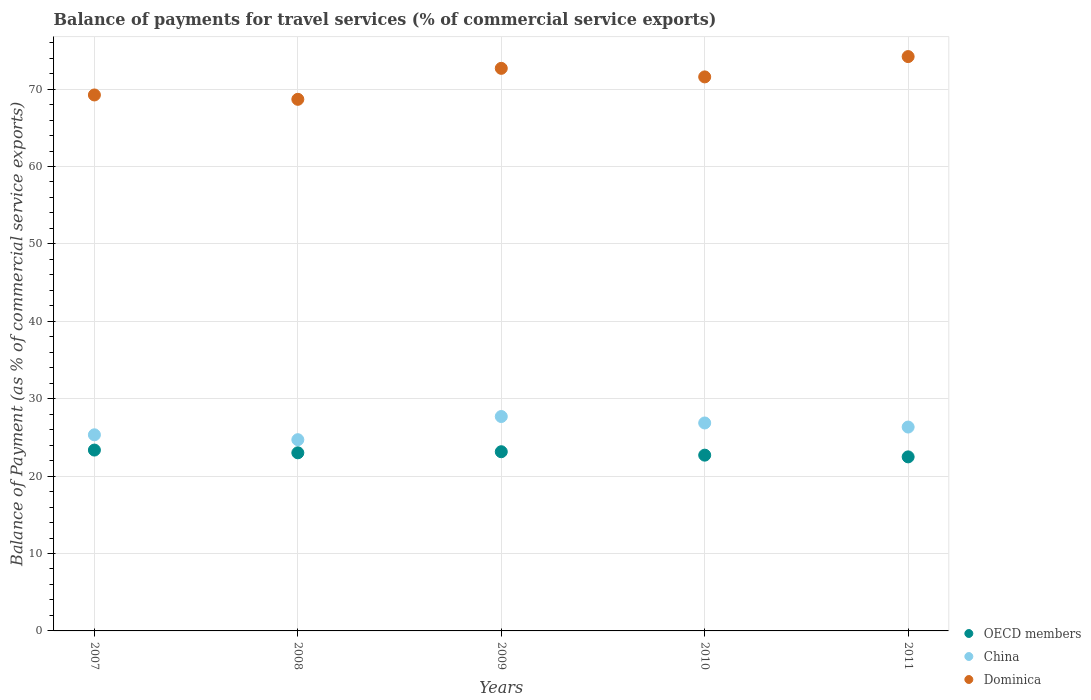Is the number of dotlines equal to the number of legend labels?
Give a very brief answer. Yes. What is the balance of payments for travel services in Dominica in 2010?
Keep it short and to the point. 71.57. Across all years, what is the maximum balance of payments for travel services in OECD members?
Your response must be concise. 23.36. Across all years, what is the minimum balance of payments for travel services in China?
Your answer should be compact. 24.7. In which year was the balance of payments for travel services in Dominica maximum?
Your answer should be compact. 2011. In which year was the balance of payments for travel services in OECD members minimum?
Your answer should be very brief. 2011. What is the total balance of payments for travel services in OECD members in the graph?
Offer a very short reply. 114.72. What is the difference between the balance of payments for travel services in Dominica in 2007 and that in 2011?
Make the answer very short. -4.96. What is the difference between the balance of payments for travel services in Dominica in 2011 and the balance of payments for travel services in China in 2008?
Give a very brief answer. 49.49. What is the average balance of payments for travel services in Dominica per year?
Offer a very short reply. 71.27. In the year 2011, what is the difference between the balance of payments for travel services in OECD members and balance of payments for travel services in Dominica?
Provide a short and direct response. -51.71. In how many years, is the balance of payments for travel services in Dominica greater than 66 %?
Give a very brief answer. 5. What is the ratio of the balance of payments for travel services in Dominica in 2007 to that in 2010?
Your answer should be compact. 0.97. Is the difference between the balance of payments for travel services in OECD members in 2008 and 2010 greater than the difference between the balance of payments for travel services in Dominica in 2008 and 2010?
Provide a succinct answer. Yes. What is the difference between the highest and the second highest balance of payments for travel services in China?
Provide a short and direct response. 0.83. What is the difference between the highest and the lowest balance of payments for travel services in OECD members?
Give a very brief answer. 0.88. In how many years, is the balance of payments for travel services in OECD members greater than the average balance of payments for travel services in OECD members taken over all years?
Offer a very short reply. 3. Is the sum of the balance of payments for travel services in OECD members in 2009 and 2011 greater than the maximum balance of payments for travel services in China across all years?
Keep it short and to the point. Yes. Is it the case that in every year, the sum of the balance of payments for travel services in OECD members and balance of payments for travel services in Dominica  is greater than the balance of payments for travel services in China?
Your answer should be compact. Yes. Is the balance of payments for travel services in China strictly greater than the balance of payments for travel services in OECD members over the years?
Ensure brevity in your answer.  Yes. Is the balance of payments for travel services in Dominica strictly less than the balance of payments for travel services in China over the years?
Your answer should be very brief. No. Are the values on the major ticks of Y-axis written in scientific E-notation?
Offer a very short reply. No. How are the legend labels stacked?
Your answer should be very brief. Vertical. What is the title of the graph?
Give a very brief answer. Balance of payments for travel services (% of commercial service exports). Does "St. Martin (French part)" appear as one of the legend labels in the graph?
Offer a terse response. No. What is the label or title of the X-axis?
Give a very brief answer. Years. What is the label or title of the Y-axis?
Provide a short and direct response. Balance of Payment (as % of commercial service exports). What is the Balance of Payment (as % of commercial service exports) of OECD members in 2007?
Offer a terse response. 23.36. What is the Balance of Payment (as % of commercial service exports) in China in 2007?
Provide a short and direct response. 25.34. What is the Balance of Payment (as % of commercial service exports) in Dominica in 2007?
Give a very brief answer. 69.24. What is the Balance of Payment (as % of commercial service exports) in OECD members in 2008?
Provide a succinct answer. 23.01. What is the Balance of Payment (as % of commercial service exports) of China in 2008?
Offer a very short reply. 24.7. What is the Balance of Payment (as % of commercial service exports) in Dominica in 2008?
Offer a very short reply. 68.68. What is the Balance of Payment (as % of commercial service exports) in OECD members in 2009?
Give a very brief answer. 23.15. What is the Balance of Payment (as % of commercial service exports) in China in 2009?
Ensure brevity in your answer.  27.7. What is the Balance of Payment (as % of commercial service exports) in Dominica in 2009?
Your response must be concise. 72.68. What is the Balance of Payment (as % of commercial service exports) in OECD members in 2010?
Your response must be concise. 22.71. What is the Balance of Payment (as % of commercial service exports) of China in 2010?
Offer a terse response. 26.86. What is the Balance of Payment (as % of commercial service exports) of Dominica in 2010?
Provide a succinct answer. 71.57. What is the Balance of Payment (as % of commercial service exports) in OECD members in 2011?
Offer a very short reply. 22.48. What is the Balance of Payment (as % of commercial service exports) in China in 2011?
Offer a very short reply. 26.34. What is the Balance of Payment (as % of commercial service exports) in Dominica in 2011?
Ensure brevity in your answer.  74.2. Across all years, what is the maximum Balance of Payment (as % of commercial service exports) of OECD members?
Your answer should be very brief. 23.36. Across all years, what is the maximum Balance of Payment (as % of commercial service exports) of China?
Provide a succinct answer. 27.7. Across all years, what is the maximum Balance of Payment (as % of commercial service exports) of Dominica?
Provide a succinct answer. 74.2. Across all years, what is the minimum Balance of Payment (as % of commercial service exports) of OECD members?
Give a very brief answer. 22.48. Across all years, what is the minimum Balance of Payment (as % of commercial service exports) of China?
Provide a short and direct response. 24.7. Across all years, what is the minimum Balance of Payment (as % of commercial service exports) in Dominica?
Provide a short and direct response. 68.68. What is the total Balance of Payment (as % of commercial service exports) of OECD members in the graph?
Make the answer very short. 114.72. What is the total Balance of Payment (as % of commercial service exports) in China in the graph?
Ensure brevity in your answer.  130.94. What is the total Balance of Payment (as % of commercial service exports) of Dominica in the graph?
Provide a short and direct response. 356.37. What is the difference between the Balance of Payment (as % of commercial service exports) of OECD members in 2007 and that in 2008?
Ensure brevity in your answer.  0.35. What is the difference between the Balance of Payment (as % of commercial service exports) of China in 2007 and that in 2008?
Your answer should be very brief. 0.63. What is the difference between the Balance of Payment (as % of commercial service exports) of Dominica in 2007 and that in 2008?
Provide a succinct answer. 0.56. What is the difference between the Balance of Payment (as % of commercial service exports) in OECD members in 2007 and that in 2009?
Provide a succinct answer. 0.21. What is the difference between the Balance of Payment (as % of commercial service exports) in China in 2007 and that in 2009?
Offer a very short reply. -2.36. What is the difference between the Balance of Payment (as % of commercial service exports) of Dominica in 2007 and that in 2009?
Your answer should be very brief. -3.44. What is the difference between the Balance of Payment (as % of commercial service exports) in OECD members in 2007 and that in 2010?
Provide a short and direct response. 0.66. What is the difference between the Balance of Payment (as % of commercial service exports) of China in 2007 and that in 2010?
Ensure brevity in your answer.  -1.53. What is the difference between the Balance of Payment (as % of commercial service exports) in Dominica in 2007 and that in 2010?
Offer a very short reply. -2.33. What is the difference between the Balance of Payment (as % of commercial service exports) in OECD members in 2007 and that in 2011?
Provide a succinct answer. 0.88. What is the difference between the Balance of Payment (as % of commercial service exports) of China in 2007 and that in 2011?
Your answer should be very brief. -1. What is the difference between the Balance of Payment (as % of commercial service exports) in Dominica in 2007 and that in 2011?
Your answer should be compact. -4.96. What is the difference between the Balance of Payment (as % of commercial service exports) of OECD members in 2008 and that in 2009?
Give a very brief answer. -0.14. What is the difference between the Balance of Payment (as % of commercial service exports) in China in 2008 and that in 2009?
Your answer should be compact. -2.99. What is the difference between the Balance of Payment (as % of commercial service exports) in Dominica in 2008 and that in 2009?
Your answer should be compact. -4. What is the difference between the Balance of Payment (as % of commercial service exports) of OECD members in 2008 and that in 2010?
Your answer should be compact. 0.3. What is the difference between the Balance of Payment (as % of commercial service exports) of China in 2008 and that in 2010?
Provide a succinct answer. -2.16. What is the difference between the Balance of Payment (as % of commercial service exports) of Dominica in 2008 and that in 2010?
Offer a very short reply. -2.9. What is the difference between the Balance of Payment (as % of commercial service exports) of OECD members in 2008 and that in 2011?
Make the answer very short. 0.53. What is the difference between the Balance of Payment (as % of commercial service exports) in China in 2008 and that in 2011?
Your answer should be very brief. -1.63. What is the difference between the Balance of Payment (as % of commercial service exports) of Dominica in 2008 and that in 2011?
Offer a very short reply. -5.52. What is the difference between the Balance of Payment (as % of commercial service exports) in OECD members in 2009 and that in 2010?
Keep it short and to the point. 0.44. What is the difference between the Balance of Payment (as % of commercial service exports) in China in 2009 and that in 2010?
Your response must be concise. 0.83. What is the difference between the Balance of Payment (as % of commercial service exports) in Dominica in 2009 and that in 2010?
Offer a very short reply. 1.1. What is the difference between the Balance of Payment (as % of commercial service exports) in OECD members in 2009 and that in 2011?
Your answer should be compact. 0.67. What is the difference between the Balance of Payment (as % of commercial service exports) in China in 2009 and that in 2011?
Your response must be concise. 1.36. What is the difference between the Balance of Payment (as % of commercial service exports) in Dominica in 2009 and that in 2011?
Give a very brief answer. -1.52. What is the difference between the Balance of Payment (as % of commercial service exports) in OECD members in 2010 and that in 2011?
Make the answer very short. 0.22. What is the difference between the Balance of Payment (as % of commercial service exports) of China in 2010 and that in 2011?
Ensure brevity in your answer.  0.53. What is the difference between the Balance of Payment (as % of commercial service exports) in Dominica in 2010 and that in 2011?
Your answer should be very brief. -2.62. What is the difference between the Balance of Payment (as % of commercial service exports) in OECD members in 2007 and the Balance of Payment (as % of commercial service exports) in China in 2008?
Offer a terse response. -1.34. What is the difference between the Balance of Payment (as % of commercial service exports) of OECD members in 2007 and the Balance of Payment (as % of commercial service exports) of Dominica in 2008?
Ensure brevity in your answer.  -45.31. What is the difference between the Balance of Payment (as % of commercial service exports) of China in 2007 and the Balance of Payment (as % of commercial service exports) of Dominica in 2008?
Provide a short and direct response. -43.34. What is the difference between the Balance of Payment (as % of commercial service exports) of OECD members in 2007 and the Balance of Payment (as % of commercial service exports) of China in 2009?
Your answer should be very brief. -4.33. What is the difference between the Balance of Payment (as % of commercial service exports) of OECD members in 2007 and the Balance of Payment (as % of commercial service exports) of Dominica in 2009?
Make the answer very short. -49.31. What is the difference between the Balance of Payment (as % of commercial service exports) of China in 2007 and the Balance of Payment (as % of commercial service exports) of Dominica in 2009?
Offer a terse response. -47.34. What is the difference between the Balance of Payment (as % of commercial service exports) in OECD members in 2007 and the Balance of Payment (as % of commercial service exports) in China in 2010?
Your response must be concise. -3.5. What is the difference between the Balance of Payment (as % of commercial service exports) of OECD members in 2007 and the Balance of Payment (as % of commercial service exports) of Dominica in 2010?
Give a very brief answer. -48.21. What is the difference between the Balance of Payment (as % of commercial service exports) of China in 2007 and the Balance of Payment (as % of commercial service exports) of Dominica in 2010?
Keep it short and to the point. -46.24. What is the difference between the Balance of Payment (as % of commercial service exports) of OECD members in 2007 and the Balance of Payment (as % of commercial service exports) of China in 2011?
Your response must be concise. -2.97. What is the difference between the Balance of Payment (as % of commercial service exports) of OECD members in 2007 and the Balance of Payment (as % of commercial service exports) of Dominica in 2011?
Provide a succinct answer. -50.83. What is the difference between the Balance of Payment (as % of commercial service exports) of China in 2007 and the Balance of Payment (as % of commercial service exports) of Dominica in 2011?
Give a very brief answer. -48.86. What is the difference between the Balance of Payment (as % of commercial service exports) of OECD members in 2008 and the Balance of Payment (as % of commercial service exports) of China in 2009?
Offer a very short reply. -4.69. What is the difference between the Balance of Payment (as % of commercial service exports) in OECD members in 2008 and the Balance of Payment (as % of commercial service exports) in Dominica in 2009?
Your response must be concise. -49.67. What is the difference between the Balance of Payment (as % of commercial service exports) of China in 2008 and the Balance of Payment (as % of commercial service exports) of Dominica in 2009?
Offer a very short reply. -47.97. What is the difference between the Balance of Payment (as % of commercial service exports) of OECD members in 2008 and the Balance of Payment (as % of commercial service exports) of China in 2010?
Provide a succinct answer. -3.85. What is the difference between the Balance of Payment (as % of commercial service exports) of OECD members in 2008 and the Balance of Payment (as % of commercial service exports) of Dominica in 2010?
Provide a short and direct response. -48.56. What is the difference between the Balance of Payment (as % of commercial service exports) of China in 2008 and the Balance of Payment (as % of commercial service exports) of Dominica in 2010?
Your response must be concise. -46.87. What is the difference between the Balance of Payment (as % of commercial service exports) of OECD members in 2008 and the Balance of Payment (as % of commercial service exports) of China in 2011?
Your response must be concise. -3.33. What is the difference between the Balance of Payment (as % of commercial service exports) of OECD members in 2008 and the Balance of Payment (as % of commercial service exports) of Dominica in 2011?
Provide a succinct answer. -51.19. What is the difference between the Balance of Payment (as % of commercial service exports) in China in 2008 and the Balance of Payment (as % of commercial service exports) in Dominica in 2011?
Your answer should be very brief. -49.49. What is the difference between the Balance of Payment (as % of commercial service exports) of OECD members in 2009 and the Balance of Payment (as % of commercial service exports) of China in 2010?
Keep it short and to the point. -3.71. What is the difference between the Balance of Payment (as % of commercial service exports) of OECD members in 2009 and the Balance of Payment (as % of commercial service exports) of Dominica in 2010?
Keep it short and to the point. -48.42. What is the difference between the Balance of Payment (as % of commercial service exports) in China in 2009 and the Balance of Payment (as % of commercial service exports) in Dominica in 2010?
Provide a short and direct response. -43.88. What is the difference between the Balance of Payment (as % of commercial service exports) in OECD members in 2009 and the Balance of Payment (as % of commercial service exports) in China in 2011?
Your answer should be compact. -3.19. What is the difference between the Balance of Payment (as % of commercial service exports) of OECD members in 2009 and the Balance of Payment (as % of commercial service exports) of Dominica in 2011?
Provide a succinct answer. -51.05. What is the difference between the Balance of Payment (as % of commercial service exports) in China in 2009 and the Balance of Payment (as % of commercial service exports) in Dominica in 2011?
Your response must be concise. -46.5. What is the difference between the Balance of Payment (as % of commercial service exports) in OECD members in 2010 and the Balance of Payment (as % of commercial service exports) in China in 2011?
Keep it short and to the point. -3.63. What is the difference between the Balance of Payment (as % of commercial service exports) of OECD members in 2010 and the Balance of Payment (as % of commercial service exports) of Dominica in 2011?
Offer a terse response. -51.49. What is the difference between the Balance of Payment (as % of commercial service exports) in China in 2010 and the Balance of Payment (as % of commercial service exports) in Dominica in 2011?
Give a very brief answer. -47.33. What is the average Balance of Payment (as % of commercial service exports) of OECD members per year?
Make the answer very short. 22.94. What is the average Balance of Payment (as % of commercial service exports) of China per year?
Give a very brief answer. 26.19. What is the average Balance of Payment (as % of commercial service exports) in Dominica per year?
Provide a succinct answer. 71.27. In the year 2007, what is the difference between the Balance of Payment (as % of commercial service exports) in OECD members and Balance of Payment (as % of commercial service exports) in China?
Offer a terse response. -1.97. In the year 2007, what is the difference between the Balance of Payment (as % of commercial service exports) of OECD members and Balance of Payment (as % of commercial service exports) of Dominica?
Your response must be concise. -45.88. In the year 2007, what is the difference between the Balance of Payment (as % of commercial service exports) of China and Balance of Payment (as % of commercial service exports) of Dominica?
Keep it short and to the point. -43.91. In the year 2008, what is the difference between the Balance of Payment (as % of commercial service exports) in OECD members and Balance of Payment (as % of commercial service exports) in China?
Keep it short and to the point. -1.69. In the year 2008, what is the difference between the Balance of Payment (as % of commercial service exports) of OECD members and Balance of Payment (as % of commercial service exports) of Dominica?
Your answer should be compact. -45.67. In the year 2008, what is the difference between the Balance of Payment (as % of commercial service exports) of China and Balance of Payment (as % of commercial service exports) of Dominica?
Offer a very short reply. -43.97. In the year 2009, what is the difference between the Balance of Payment (as % of commercial service exports) of OECD members and Balance of Payment (as % of commercial service exports) of China?
Offer a terse response. -4.55. In the year 2009, what is the difference between the Balance of Payment (as % of commercial service exports) in OECD members and Balance of Payment (as % of commercial service exports) in Dominica?
Offer a terse response. -49.53. In the year 2009, what is the difference between the Balance of Payment (as % of commercial service exports) in China and Balance of Payment (as % of commercial service exports) in Dominica?
Ensure brevity in your answer.  -44.98. In the year 2010, what is the difference between the Balance of Payment (as % of commercial service exports) in OECD members and Balance of Payment (as % of commercial service exports) in China?
Your response must be concise. -4.16. In the year 2010, what is the difference between the Balance of Payment (as % of commercial service exports) of OECD members and Balance of Payment (as % of commercial service exports) of Dominica?
Offer a terse response. -48.87. In the year 2010, what is the difference between the Balance of Payment (as % of commercial service exports) of China and Balance of Payment (as % of commercial service exports) of Dominica?
Provide a short and direct response. -44.71. In the year 2011, what is the difference between the Balance of Payment (as % of commercial service exports) of OECD members and Balance of Payment (as % of commercial service exports) of China?
Provide a short and direct response. -3.85. In the year 2011, what is the difference between the Balance of Payment (as % of commercial service exports) of OECD members and Balance of Payment (as % of commercial service exports) of Dominica?
Your answer should be compact. -51.71. In the year 2011, what is the difference between the Balance of Payment (as % of commercial service exports) of China and Balance of Payment (as % of commercial service exports) of Dominica?
Your response must be concise. -47.86. What is the ratio of the Balance of Payment (as % of commercial service exports) of OECD members in 2007 to that in 2008?
Keep it short and to the point. 1.02. What is the ratio of the Balance of Payment (as % of commercial service exports) in China in 2007 to that in 2008?
Provide a succinct answer. 1.03. What is the ratio of the Balance of Payment (as % of commercial service exports) of Dominica in 2007 to that in 2008?
Your answer should be compact. 1.01. What is the ratio of the Balance of Payment (as % of commercial service exports) in OECD members in 2007 to that in 2009?
Your answer should be very brief. 1.01. What is the ratio of the Balance of Payment (as % of commercial service exports) in China in 2007 to that in 2009?
Provide a succinct answer. 0.91. What is the ratio of the Balance of Payment (as % of commercial service exports) of Dominica in 2007 to that in 2009?
Ensure brevity in your answer.  0.95. What is the ratio of the Balance of Payment (as % of commercial service exports) of OECD members in 2007 to that in 2010?
Give a very brief answer. 1.03. What is the ratio of the Balance of Payment (as % of commercial service exports) of China in 2007 to that in 2010?
Your answer should be very brief. 0.94. What is the ratio of the Balance of Payment (as % of commercial service exports) of Dominica in 2007 to that in 2010?
Provide a succinct answer. 0.97. What is the ratio of the Balance of Payment (as % of commercial service exports) of OECD members in 2007 to that in 2011?
Ensure brevity in your answer.  1.04. What is the ratio of the Balance of Payment (as % of commercial service exports) in China in 2007 to that in 2011?
Provide a short and direct response. 0.96. What is the ratio of the Balance of Payment (as % of commercial service exports) of Dominica in 2007 to that in 2011?
Your answer should be very brief. 0.93. What is the ratio of the Balance of Payment (as % of commercial service exports) in OECD members in 2008 to that in 2009?
Provide a succinct answer. 0.99. What is the ratio of the Balance of Payment (as % of commercial service exports) in China in 2008 to that in 2009?
Keep it short and to the point. 0.89. What is the ratio of the Balance of Payment (as % of commercial service exports) in Dominica in 2008 to that in 2009?
Your answer should be compact. 0.94. What is the ratio of the Balance of Payment (as % of commercial service exports) in OECD members in 2008 to that in 2010?
Ensure brevity in your answer.  1.01. What is the ratio of the Balance of Payment (as % of commercial service exports) in China in 2008 to that in 2010?
Your response must be concise. 0.92. What is the ratio of the Balance of Payment (as % of commercial service exports) in Dominica in 2008 to that in 2010?
Provide a short and direct response. 0.96. What is the ratio of the Balance of Payment (as % of commercial service exports) of OECD members in 2008 to that in 2011?
Your answer should be very brief. 1.02. What is the ratio of the Balance of Payment (as % of commercial service exports) in China in 2008 to that in 2011?
Provide a short and direct response. 0.94. What is the ratio of the Balance of Payment (as % of commercial service exports) in Dominica in 2008 to that in 2011?
Offer a terse response. 0.93. What is the ratio of the Balance of Payment (as % of commercial service exports) in OECD members in 2009 to that in 2010?
Make the answer very short. 1.02. What is the ratio of the Balance of Payment (as % of commercial service exports) in China in 2009 to that in 2010?
Your response must be concise. 1.03. What is the ratio of the Balance of Payment (as % of commercial service exports) of Dominica in 2009 to that in 2010?
Make the answer very short. 1.02. What is the ratio of the Balance of Payment (as % of commercial service exports) of OECD members in 2009 to that in 2011?
Your answer should be compact. 1.03. What is the ratio of the Balance of Payment (as % of commercial service exports) of China in 2009 to that in 2011?
Make the answer very short. 1.05. What is the ratio of the Balance of Payment (as % of commercial service exports) of Dominica in 2009 to that in 2011?
Your response must be concise. 0.98. What is the ratio of the Balance of Payment (as % of commercial service exports) in OECD members in 2010 to that in 2011?
Provide a short and direct response. 1.01. What is the ratio of the Balance of Payment (as % of commercial service exports) in Dominica in 2010 to that in 2011?
Make the answer very short. 0.96. What is the difference between the highest and the second highest Balance of Payment (as % of commercial service exports) of OECD members?
Offer a terse response. 0.21. What is the difference between the highest and the second highest Balance of Payment (as % of commercial service exports) in China?
Your response must be concise. 0.83. What is the difference between the highest and the second highest Balance of Payment (as % of commercial service exports) of Dominica?
Provide a succinct answer. 1.52. What is the difference between the highest and the lowest Balance of Payment (as % of commercial service exports) of OECD members?
Make the answer very short. 0.88. What is the difference between the highest and the lowest Balance of Payment (as % of commercial service exports) in China?
Keep it short and to the point. 2.99. What is the difference between the highest and the lowest Balance of Payment (as % of commercial service exports) in Dominica?
Give a very brief answer. 5.52. 